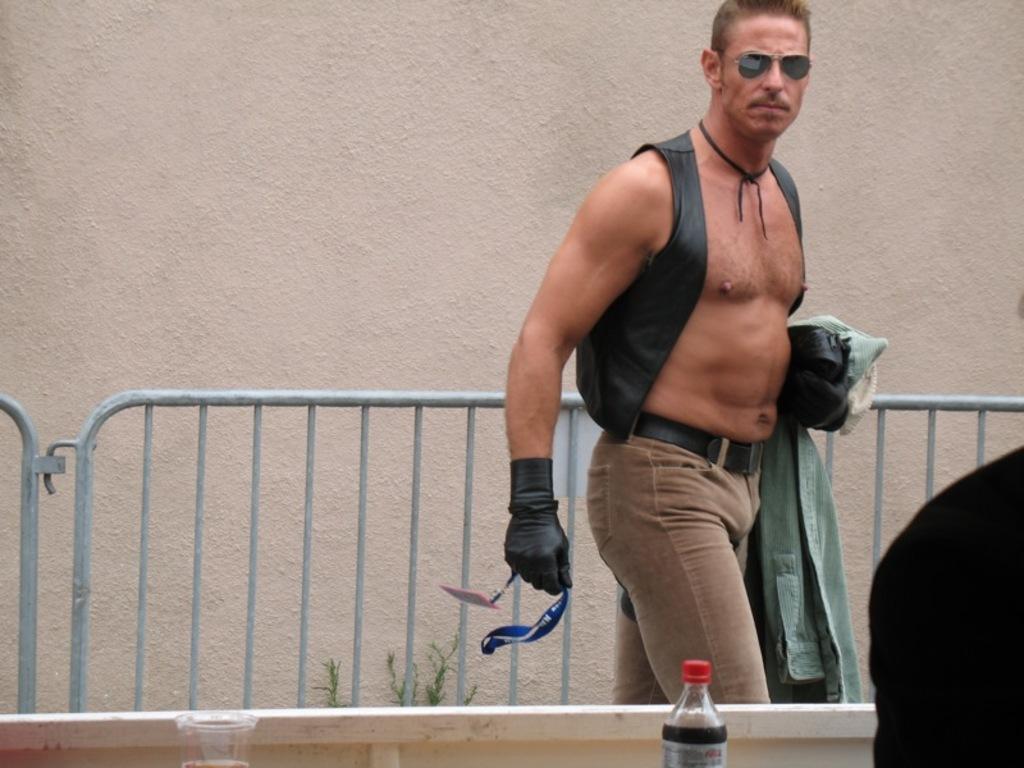How would you summarize this image in a sentence or two? In this image, we can see a man standing, there is a fencing and we can see the wall. We can see a soft drink bottle. 